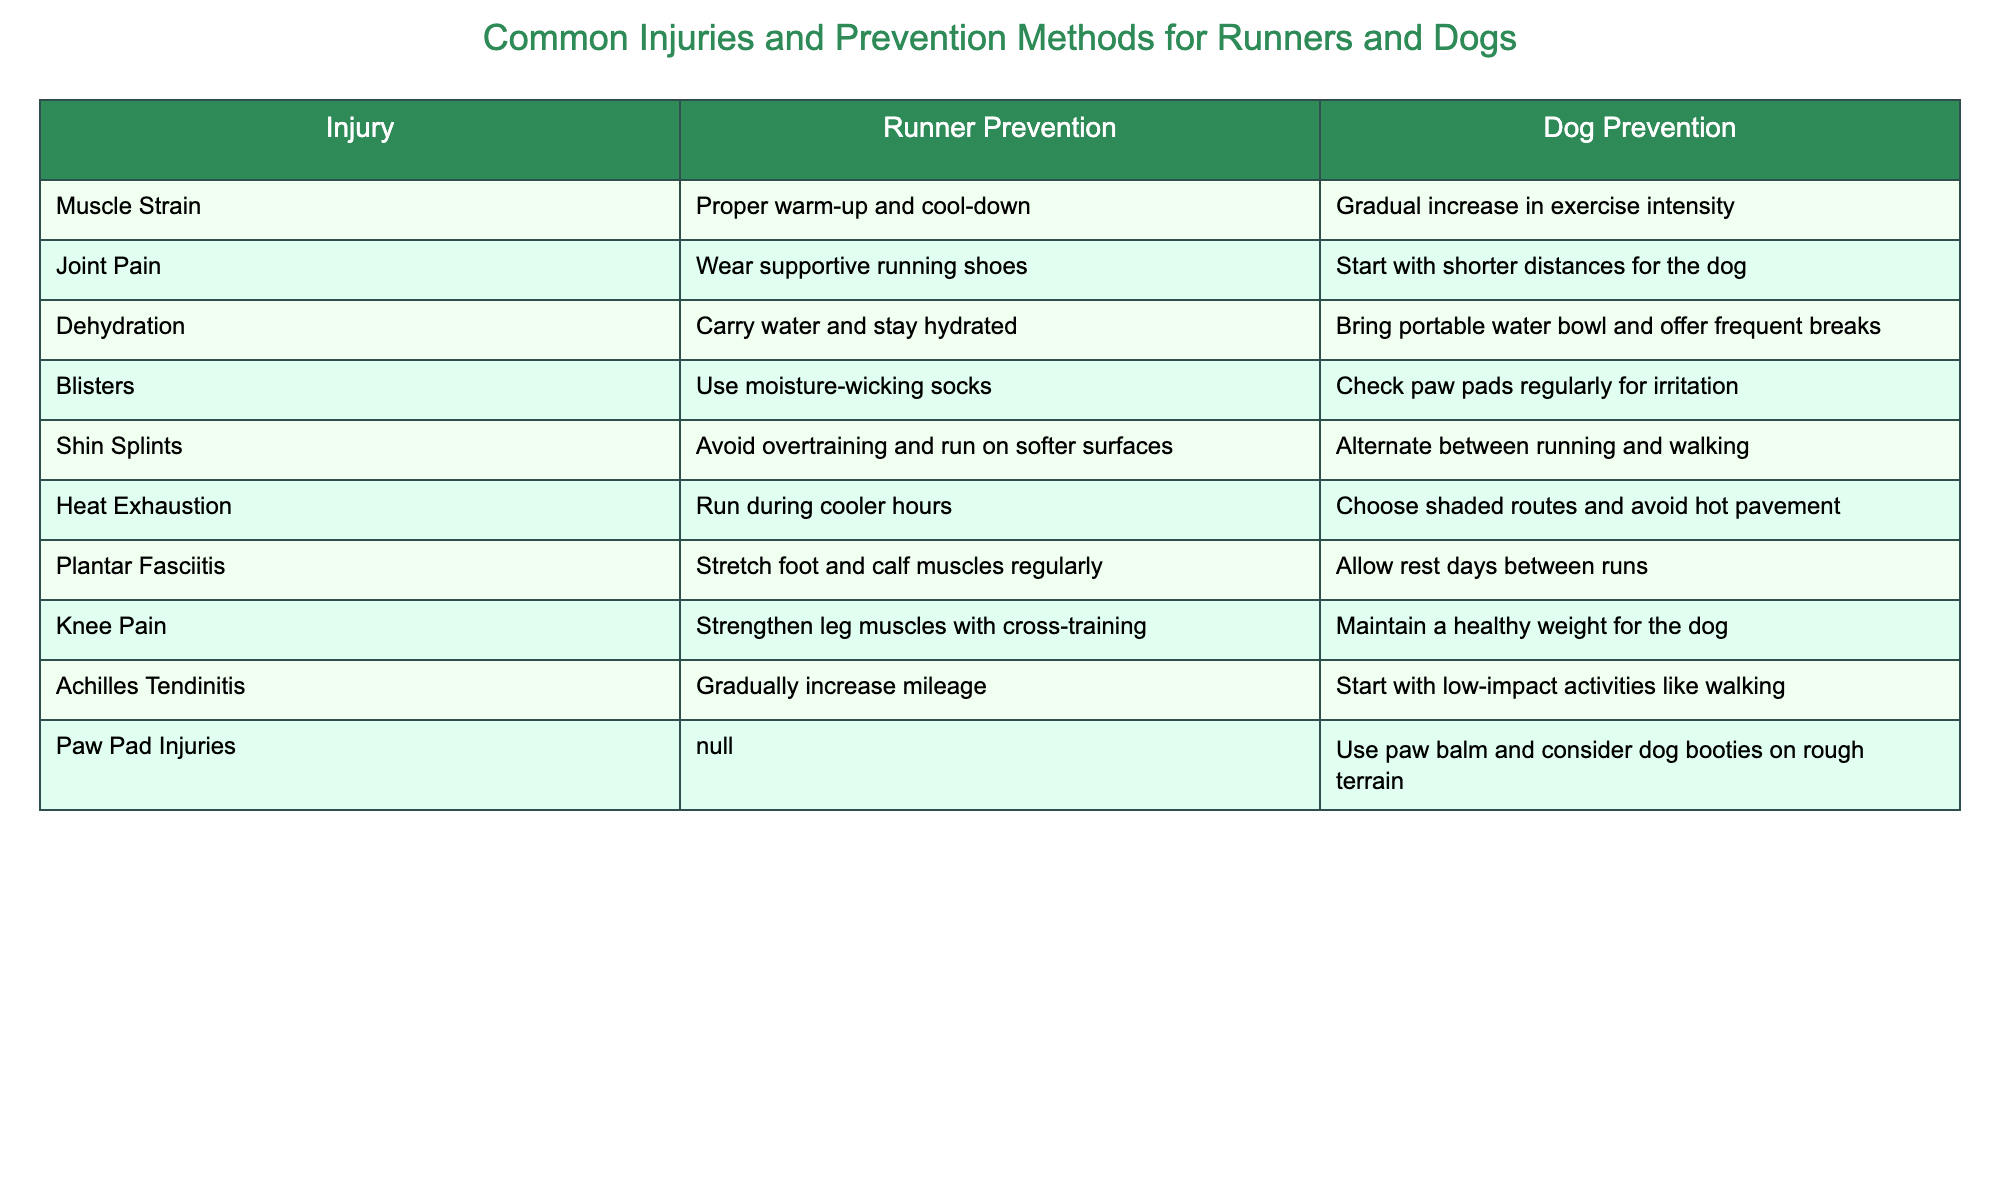What's a common preventive measure for muscle strain in runners? The table states that a common preventive measure for muscle strain in runners is to properly warm up and cool down before and after runs.
Answer: Proper warm-up and cool-down What should be done to prevent dehydration in dogs during runs? To prevent dehydration in dogs, it is important to bring a portable water bowl and offer frequent breaks, as indicated in the table.
Answer: Bring portable water bowl and offer frequent breaks Is it true that runners should avoid overtraining to prevent shin splints? Yes, according to the table, avoiding overtraining is a preventive method for shin splints in runners.
Answer: Yes What are two injuries listed for dogs, and what are their prevention methods? The injuries listed for dogs are joint pain and paw pad injuries. Their prevention methods include starting with shorter distances for joint pain and using paw balm or dog booties for paw pad injuries.
Answer: Joint pain: Start with shorter distances; Paw pad injuries: Use paw balm and consider dog booties How do the injury prevention methods for dogs differ when comparing joint pain and Achilles tendinitis? To prevent joint pain in dogs, the recommendation is to start with shorter distances, while Achilles tendinitis prevention involves starting with low-impact activities like walking. These methods differ in their approach, with one focusing on distance and the other on activity type.
Answer: Joint pain: Start with shorter distances; Achilles tendinitis: Start with low-impact activities What preventative measure for heat exhaustion in runners is mentioned, and how does it compare to the method for dogs? The table suggests that runners should run during cooler hours to prevent heat exhaustion, while for dogs, the method is to choose shaded routes and avoid hot pavement. Both methods aim to mitigate heat stress but differ in their application based on environment and activity timing.
Answer: Run during cooler hours for runners; Choose shaded routes for dogs Which prevention method is applicable only to dogs and not to runners? The prevention method mentioned for dogs that does not apply to runners is the use of paw balm and considering dog booties on rough terrain, as there is no equivalent preventative measure listed for runners.
Answer: Use paw balm and consider dog booties on rough terrain What is the difference in preventative advice for dehydration between runners and dogs? Runners are advised to carry water and stay hydrated to prevent dehydration, while dogs are recommended to have a portable water bowl and to be offered frequent breaks to stay hydrated. The focus shifts from personal hydration to providing water for the dog.
Answer: Runners: Carry water; Dogs: Bring portable water bowl and offer breaks For which injury is strict rest recommended for dogs and why? For plantar fasciitis in dogs, the prevention method is to allow rest days between runs. This is important to prevent strain and promote recovery, similar to the advice given to runners.
Answer: Allow rest days between runs for plantar fasciitis 